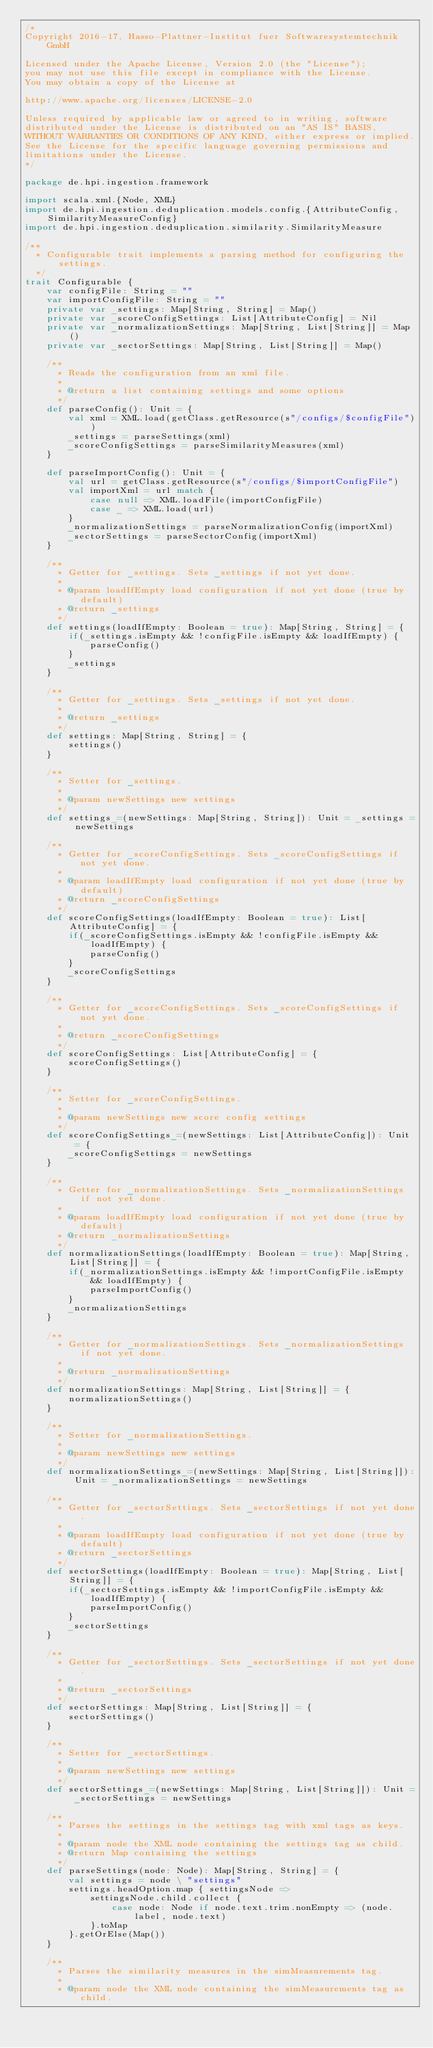Convert code to text. <code><loc_0><loc_0><loc_500><loc_500><_Scala_>/*
Copyright 2016-17, Hasso-Plattner-Institut fuer Softwaresystemtechnik GmbH

Licensed under the Apache License, Version 2.0 (the "License");
you may not use this file except in compliance with the License.
You may obtain a copy of the License at

http://www.apache.org/licenses/LICENSE-2.0

Unless required by applicable law or agreed to in writing, software
distributed under the License is distributed on an "AS IS" BASIS,
WITHOUT WARRANTIES OR CONDITIONS OF ANY KIND, either express or implied.
See the License for the specific language governing permissions and
limitations under the License.
*/

package de.hpi.ingestion.framework

import scala.xml.{Node, XML}
import de.hpi.ingestion.deduplication.models.config.{AttributeConfig, SimilarityMeasureConfig}
import de.hpi.ingestion.deduplication.similarity.SimilarityMeasure

/**
  * Configurable trait implements a parsing method for configuring the settings.
  */
trait Configurable {
    var configFile: String = ""
    var importConfigFile: String = ""
    private var _settings: Map[String, String] = Map()
    private var _scoreConfigSettings: List[AttributeConfig] = Nil
    private var _normalizationSettings: Map[String, List[String]] = Map()
    private var _sectorSettings: Map[String, List[String]] = Map()

    /**
      * Reads the configuration from an xml file.
      *
      * @return a list containing settings and some options
      */
    def parseConfig(): Unit = {
        val xml = XML.load(getClass.getResource(s"/configs/$configFile"))
        _settings = parseSettings(xml)
        _scoreConfigSettings = parseSimilarityMeasures(xml)
    }

    def parseImportConfig(): Unit = {
        val url = getClass.getResource(s"/configs/$importConfigFile")
        val importXml = url match {
            case null => XML.loadFile(importConfigFile)
            case _ => XML.load(url)
        }
        _normalizationSettings = parseNormalizationConfig(importXml)
        _sectorSettings = parseSectorConfig(importXml)
    }

    /**
      * Getter for _settings. Sets _settings if not yet done.
      *
      * @param loadIfEmpty load configuration if not yet done (true by default)
      * @return _settings
      */
    def settings(loadIfEmpty: Boolean = true): Map[String, String] = {
        if(_settings.isEmpty && !configFile.isEmpty && loadIfEmpty) {
            parseConfig()
        }
        _settings
    }

    /**
      * Getter for _settings. Sets _settings if not yet done.
      *
      * @return _settings
      */
    def settings: Map[String, String] = {
        settings()
    }

    /**
      * Setter for _settings.
      *
      * @param newSettings new settings
      */
    def settings_=(newSettings: Map[String, String]): Unit = _settings = newSettings

    /**
      * Getter for _scoreConfigSettings. Sets _scoreConfigSettings if not yet done.
      *
      * @param loadIfEmpty load configuration if not yet done (true by default)
      * @return _scoreConfigSettings
      */
    def scoreConfigSettings(loadIfEmpty: Boolean = true): List[AttributeConfig] = {
        if(_scoreConfigSettings.isEmpty && !configFile.isEmpty && loadIfEmpty) {
            parseConfig()
        }
        _scoreConfigSettings
    }

    /**
      * Getter for _scoreConfigSettings. Sets _scoreConfigSettings if not yet done.
      *
      * @return _scoreConfigSettings
      */
    def scoreConfigSettings: List[AttributeConfig] = {
        scoreConfigSettings()
    }

    /**
      * Setter for _scoreConfigSettings.
      *
      * @param newSettings new score config settings
      */
    def scoreConfigSettings_=(newSettings: List[AttributeConfig]): Unit  = {
        _scoreConfigSettings = newSettings
    }

    /**
      * Getter for _normalizationSettings. Sets _normalizationSettings if not yet done.
      *
      * @param loadIfEmpty load configuration if not yet done (true by default)
      * @return _normalizationSettings
      */
    def normalizationSettings(loadIfEmpty: Boolean = true): Map[String, List[String]] = {
        if(_normalizationSettings.isEmpty && !importConfigFile.isEmpty && loadIfEmpty) {
            parseImportConfig()
        }
        _normalizationSettings
    }

    /**
      * Getter for _normalizationSettings. Sets _normalizationSettings if not yet done.
      *
      * @return _normalizationSettings
      */
    def normalizationSettings: Map[String, List[String]] = {
        normalizationSettings()
    }

    /**
      * Setter for _normalizationSettings.
      *
      * @param newSettings new settings
      */
    def normalizationSettings_=(newSettings: Map[String, List[String]]): Unit = _normalizationSettings = newSettings

    /**
      * Getter for _sectorSettings. Sets _sectorSettings if not yet done.
      *
      * @param loadIfEmpty load configuration if not yet done (true by default)
      * @return _sectorSettings
      */
    def sectorSettings(loadIfEmpty: Boolean = true): Map[String, List[String]] = {
        if(_sectorSettings.isEmpty && !importConfigFile.isEmpty && loadIfEmpty) {
            parseImportConfig()
        }
        _sectorSettings
    }

    /**
      * Getter for _sectorSettings. Sets _sectorSettings if not yet done.
      *
      * @return _sectorSettings
      */
    def sectorSettings: Map[String, List[String]] = {
        sectorSettings()
    }

    /**
      * Setter for _sectorSettings.
      *
      * @param newSettings new settings
      */
    def sectorSettings_=(newSettings: Map[String, List[String]]): Unit = _sectorSettings = newSettings

    /**
      * Parses the settings in the settings tag with xml tags as keys.
      *
      * @param node the XML node containing the settings tag as child.
      * @return Map containing the settings
      */
    def parseSettings(node: Node): Map[String, String] = {
        val settings = node \ "settings"
        settings.headOption.map { settingsNode =>
            settingsNode.child.collect {
                case node: Node if node.text.trim.nonEmpty => (node.label, node.text)
            }.toMap
        }.getOrElse(Map())
    }

    /**
      * Parses the similarity measures in the simMeasurements tag.
      *
      * @param node the XML node containing the simMeasurements tag as child.</code> 